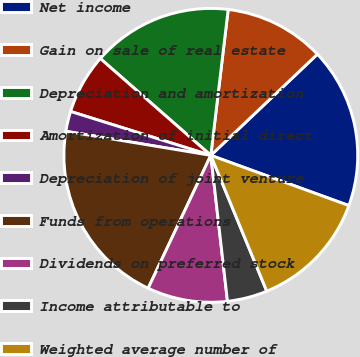Convert chart to OTSL. <chart><loc_0><loc_0><loc_500><loc_500><pie_chart><fcel>Net income<fcel>Gain on sale of real estate<fcel>Depreciation and amortization<fcel>Amortization of initial direct<fcel>Depreciation of joint venture<fcel>Funds from operations<fcel>Dividends on preferred stock<fcel>Income attributable to<fcel>Weighted average number of<nl><fcel>17.64%<fcel>11.03%<fcel>15.44%<fcel>6.62%<fcel>2.21%<fcel>20.61%<fcel>8.82%<fcel>4.41%<fcel>13.23%<nl></chart> 